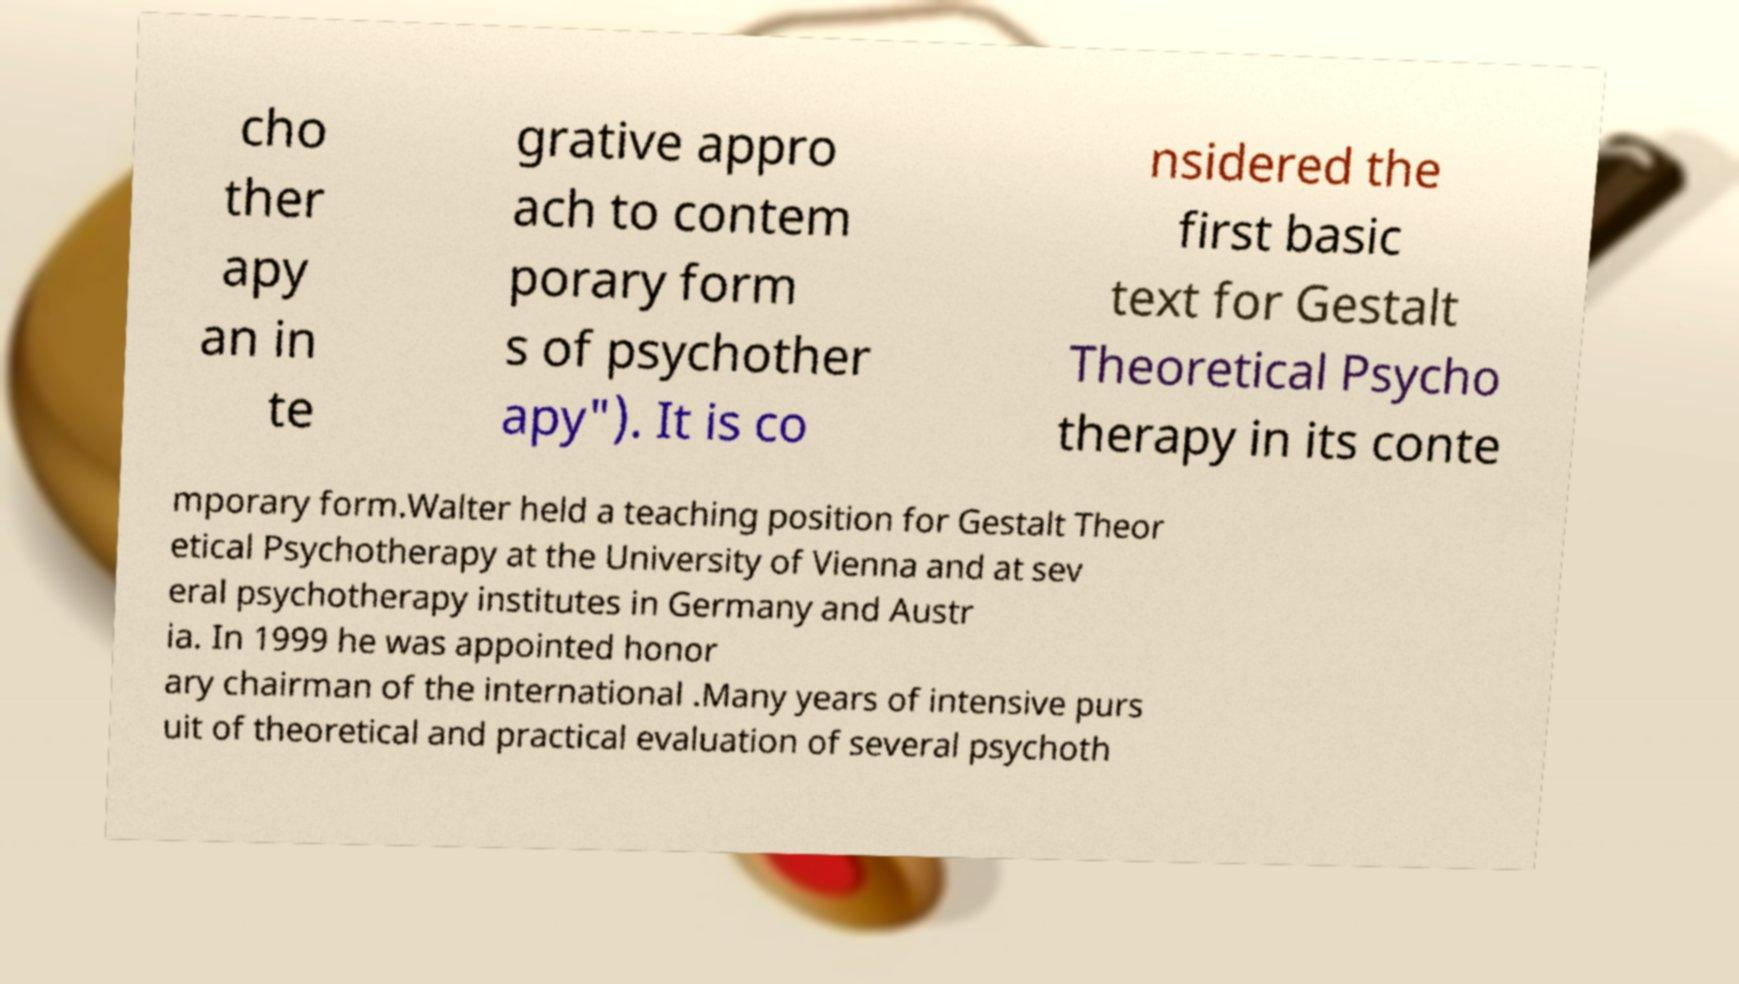There's text embedded in this image that I need extracted. Can you transcribe it verbatim? cho ther apy an in te grative appro ach to contem porary form s of psychother apy"). It is co nsidered the first basic text for Gestalt Theoretical Psycho therapy in its conte mporary form.Walter held a teaching position for Gestalt Theor etical Psychotherapy at the University of Vienna and at sev eral psychotherapy institutes in Germany and Austr ia. In 1999 he was appointed honor ary chairman of the international .Many years of intensive purs uit of theoretical and practical evaluation of several psychoth 